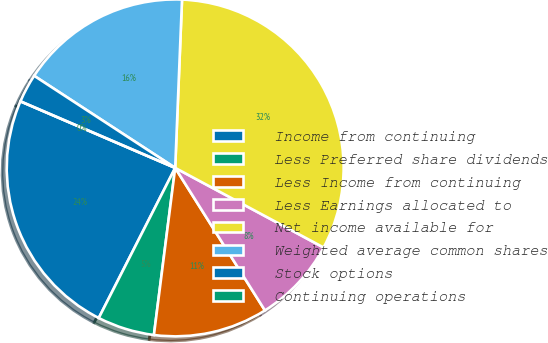Convert chart to OTSL. <chart><loc_0><loc_0><loc_500><loc_500><pie_chart><fcel>Income from continuing<fcel>Less Preferred share dividends<fcel>Less Income from continuing<fcel>Less Earnings allocated to<fcel>Net income available for<fcel>Weighted average common shares<fcel>Stock options<fcel>Continuing operations<nl><fcel>23.97%<fcel>5.48%<fcel>10.96%<fcel>8.22%<fcel>32.19%<fcel>16.44%<fcel>2.74%<fcel>0.0%<nl></chart> 